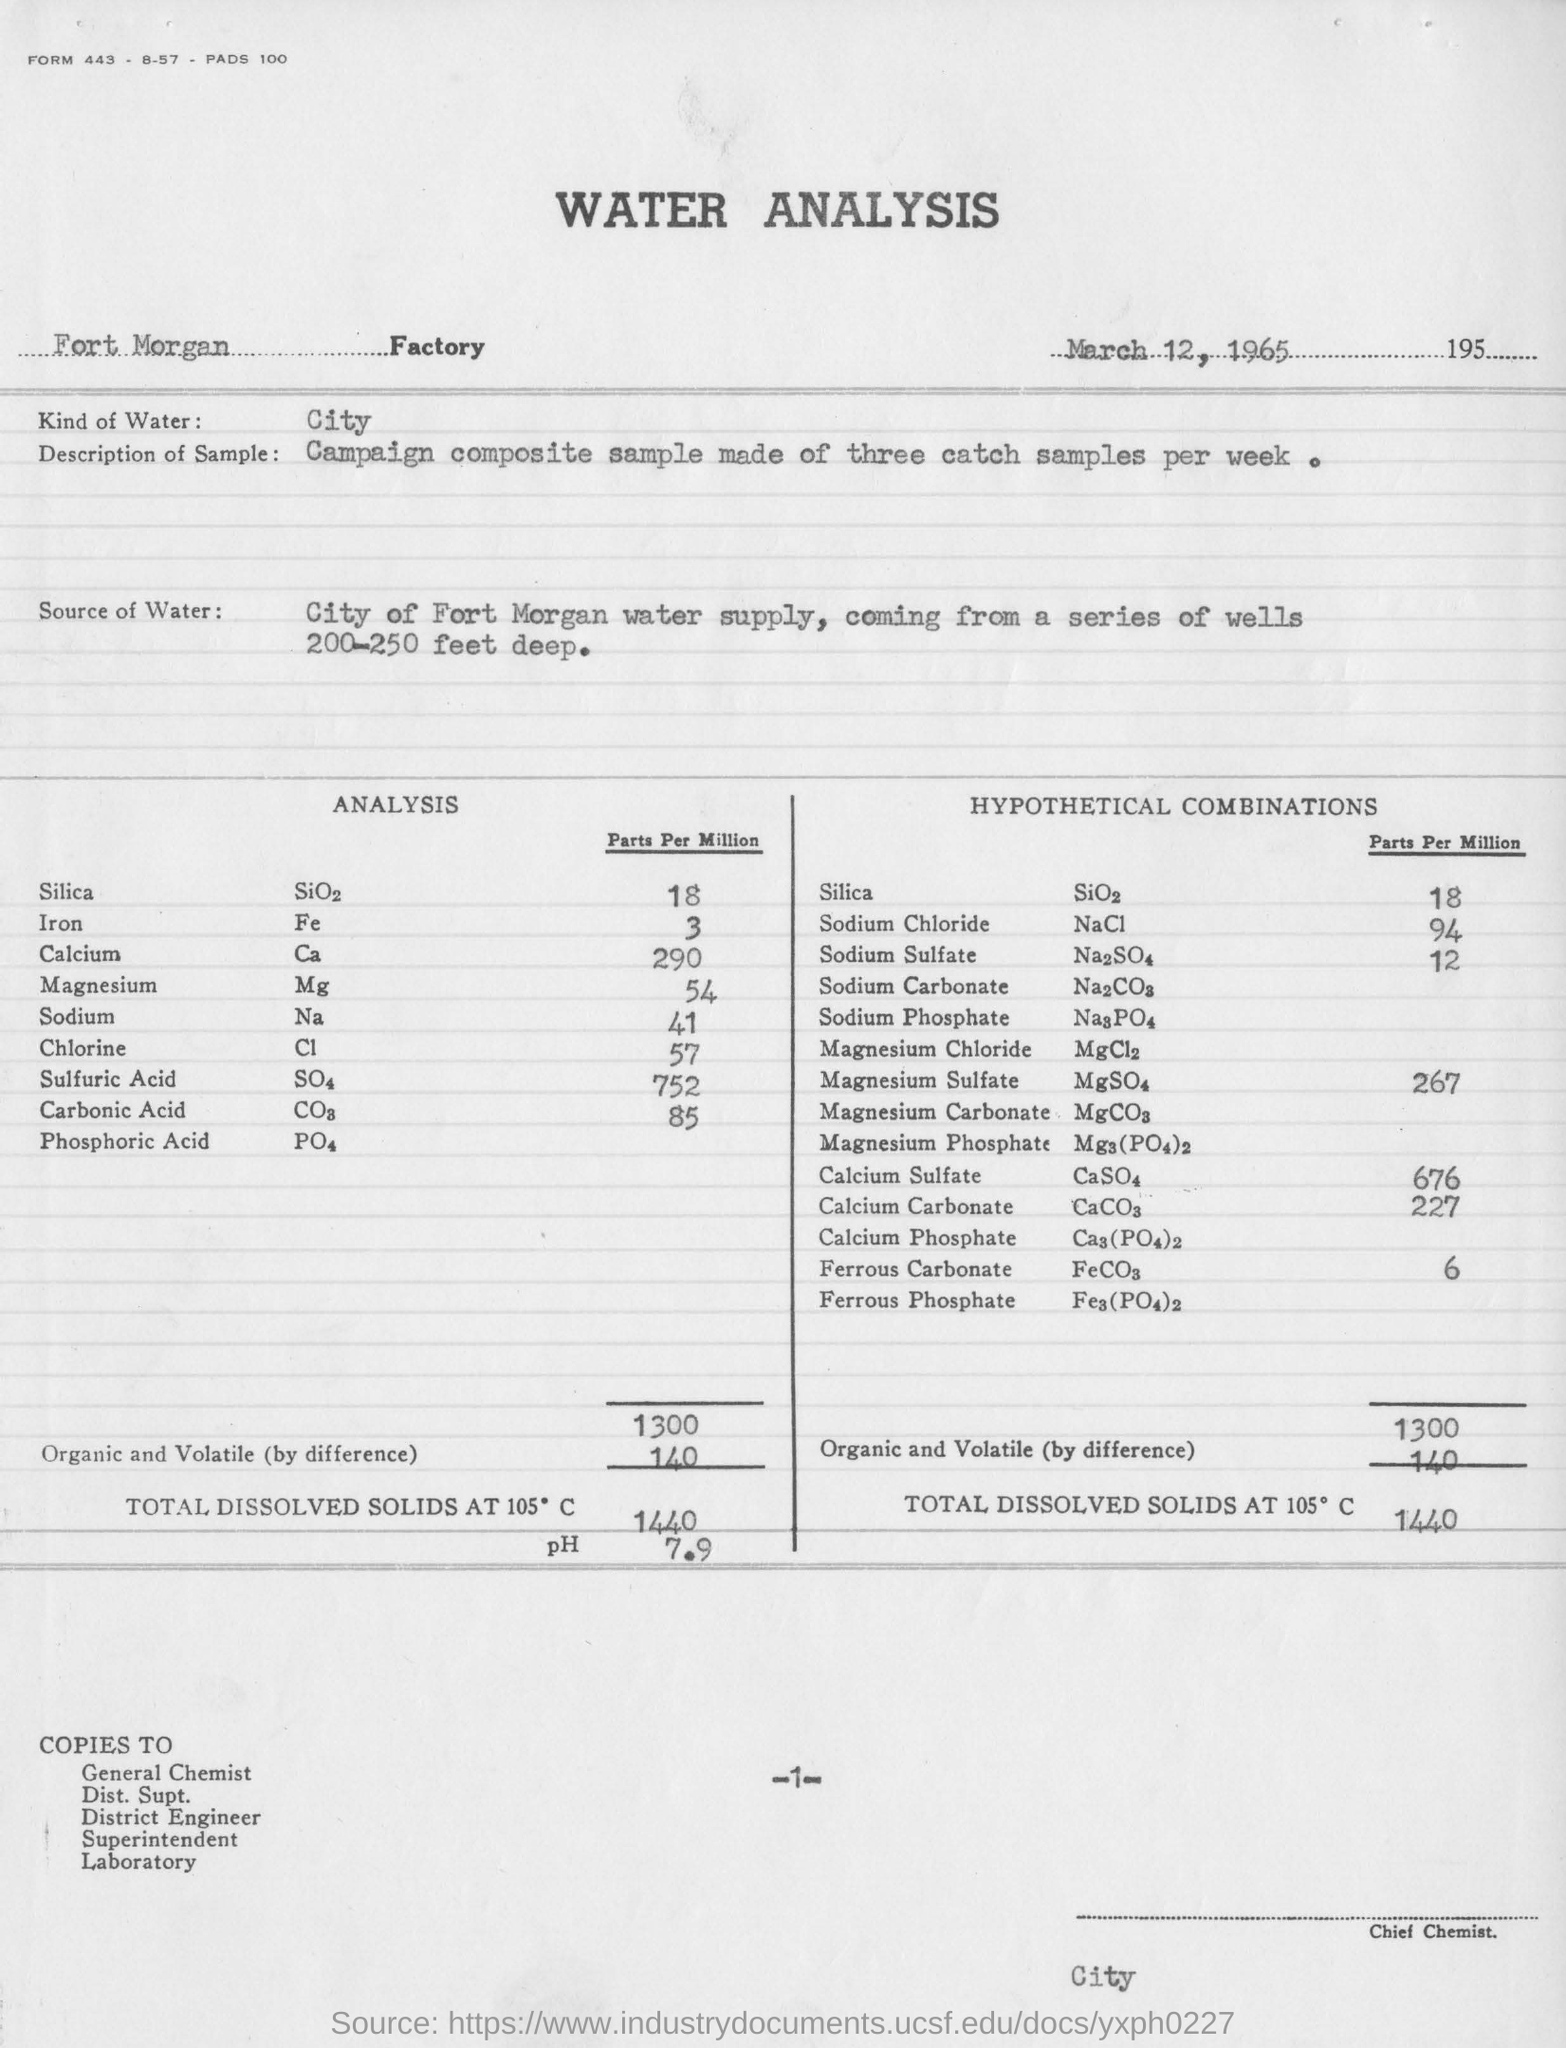What is the source of water?
Keep it short and to the point. City of Fort Morgan water supply, coming from a series of wells 200-250 feet deep. What is the date of this report?
Provide a short and direct response. March 12, 1965. What kind of water is it?
Provide a succinct answer. City. 